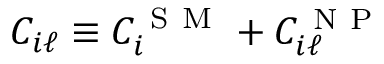<formula> <loc_0><loc_0><loc_500><loc_500>C _ { i \ell } \equiv C _ { i } ^ { S M } + C _ { i \ell } ^ { N P }</formula> 